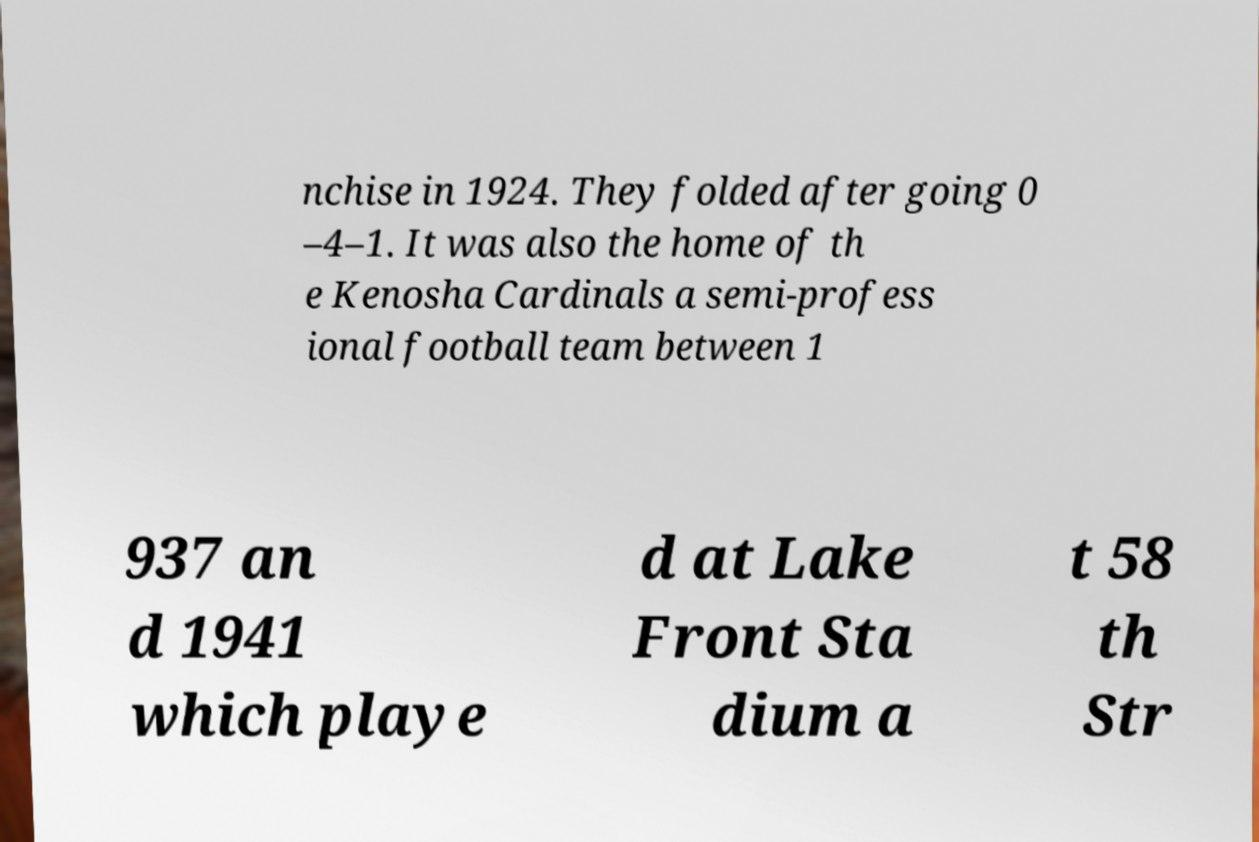There's text embedded in this image that I need extracted. Can you transcribe it verbatim? nchise in 1924. They folded after going 0 –4–1. It was also the home of th e Kenosha Cardinals a semi-profess ional football team between 1 937 an d 1941 which playe d at Lake Front Sta dium a t 58 th Str 